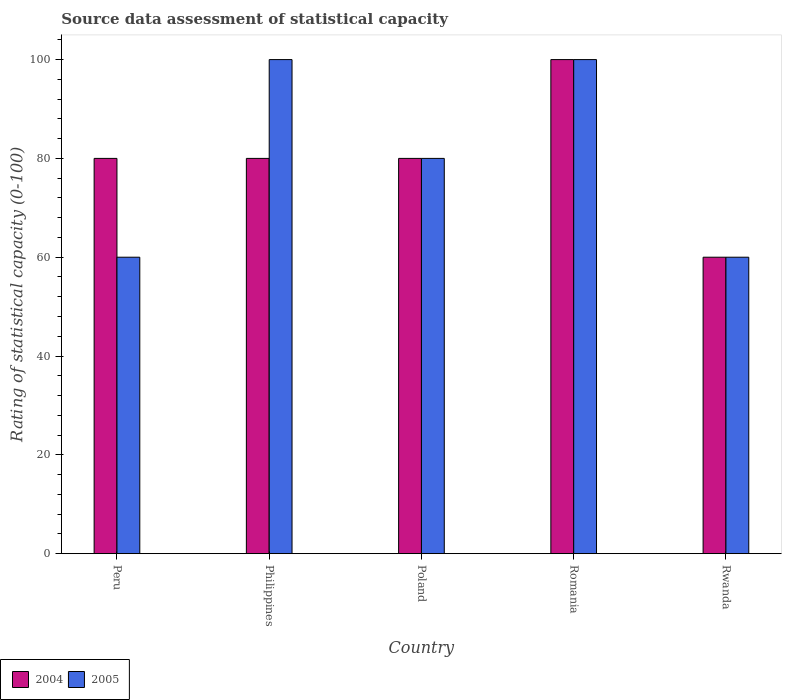How many groups of bars are there?
Your answer should be very brief. 5. Are the number of bars on each tick of the X-axis equal?
Provide a succinct answer. Yes. How many bars are there on the 5th tick from the right?
Keep it short and to the point. 2. What is the label of the 4th group of bars from the left?
Make the answer very short. Romania. Across all countries, what is the minimum rating of statistical capacity in 2004?
Make the answer very short. 60. In which country was the rating of statistical capacity in 2004 maximum?
Offer a terse response. Romania. In which country was the rating of statistical capacity in 2004 minimum?
Keep it short and to the point. Rwanda. What is the difference between the rating of statistical capacity in 2005 in Romania and the rating of statistical capacity in 2004 in Philippines?
Your answer should be compact. 20. What is the difference between the rating of statistical capacity of/in 2005 and rating of statistical capacity of/in 2004 in Philippines?
Your response must be concise. 20. What is the ratio of the rating of statistical capacity in 2005 in Poland to that in Rwanda?
Your answer should be very brief. 1.33. Is the difference between the rating of statistical capacity in 2005 in Philippines and Romania greater than the difference between the rating of statistical capacity in 2004 in Philippines and Romania?
Your answer should be very brief. Yes. What is the difference between the highest and the second highest rating of statistical capacity in 2004?
Give a very brief answer. -20. In how many countries, is the rating of statistical capacity in 2004 greater than the average rating of statistical capacity in 2004 taken over all countries?
Provide a short and direct response. 1. Is the sum of the rating of statistical capacity in 2004 in Philippines and Romania greater than the maximum rating of statistical capacity in 2005 across all countries?
Ensure brevity in your answer.  Yes. What does the 1st bar from the left in Poland represents?
Ensure brevity in your answer.  2004. What does the 2nd bar from the right in Philippines represents?
Your response must be concise. 2004. How many bars are there?
Ensure brevity in your answer.  10. Are the values on the major ticks of Y-axis written in scientific E-notation?
Offer a very short reply. No. Does the graph contain grids?
Your response must be concise. No. Where does the legend appear in the graph?
Offer a very short reply. Bottom left. How many legend labels are there?
Provide a succinct answer. 2. What is the title of the graph?
Your answer should be very brief. Source data assessment of statistical capacity. What is the label or title of the Y-axis?
Offer a very short reply. Rating of statistical capacity (0-100). What is the Rating of statistical capacity (0-100) in 2005 in Peru?
Offer a terse response. 60. What is the Rating of statistical capacity (0-100) of 2004 in Philippines?
Provide a short and direct response. 80. What is the Rating of statistical capacity (0-100) in 2005 in Poland?
Give a very brief answer. 80. What is the Rating of statistical capacity (0-100) in 2004 in Rwanda?
Provide a succinct answer. 60. Across all countries, what is the maximum Rating of statistical capacity (0-100) in 2004?
Offer a terse response. 100. Across all countries, what is the minimum Rating of statistical capacity (0-100) in 2004?
Offer a very short reply. 60. What is the total Rating of statistical capacity (0-100) in 2004 in the graph?
Your answer should be very brief. 400. What is the difference between the Rating of statistical capacity (0-100) in 2004 in Peru and that in Philippines?
Keep it short and to the point. 0. What is the difference between the Rating of statistical capacity (0-100) in 2005 in Peru and that in Poland?
Provide a short and direct response. -20. What is the difference between the Rating of statistical capacity (0-100) of 2004 in Peru and that in Romania?
Your response must be concise. -20. What is the difference between the Rating of statistical capacity (0-100) of 2004 in Peru and that in Rwanda?
Your response must be concise. 20. What is the difference between the Rating of statistical capacity (0-100) in 2005 in Peru and that in Rwanda?
Make the answer very short. 0. What is the difference between the Rating of statistical capacity (0-100) of 2004 in Philippines and that in Poland?
Give a very brief answer. 0. What is the difference between the Rating of statistical capacity (0-100) of 2005 in Philippines and that in Romania?
Your response must be concise. 0. What is the difference between the Rating of statistical capacity (0-100) in 2005 in Philippines and that in Rwanda?
Your answer should be very brief. 40. What is the difference between the Rating of statistical capacity (0-100) of 2005 in Poland and that in Rwanda?
Provide a short and direct response. 20. What is the difference between the Rating of statistical capacity (0-100) of 2005 in Romania and that in Rwanda?
Your response must be concise. 40. What is the difference between the Rating of statistical capacity (0-100) in 2004 in Peru and the Rating of statistical capacity (0-100) in 2005 in Philippines?
Your answer should be very brief. -20. What is the difference between the Rating of statistical capacity (0-100) in 2004 in Peru and the Rating of statistical capacity (0-100) in 2005 in Poland?
Provide a succinct answer. 0. What is the difference between the Rating of statistical capacity (0-100) of 2004 in Peru and the Rating of statistical capacity (0-100) of 2005 in Romania?
Offer a terse response. -20. What is the difference between the Rating of statistical capacity (0-100) in 2004 in Peru and the Rating of statistical capacity (0-100) in 2005 in Rwanda?
Your answer should be compact. 20. What is the difference between the Rating of statistical capacity (0-100) in 2004 in Poland and the Rating of statistical capacity (0-100) in 2005 in Romania?
Provide a short and direct response. -20. What is the difference between the Rating of statistical capacity (0-100) in 2004 in Romania and the Rating of statistical capacity (0-100) in 2005 in Rwanda?
Your response must be concise. 40. What is the average Rating of statistical capacity (0-100) of 2005 per country?
Your answer should be compact. 80. What is the difference between the Rating of statistical capacity (0-100) in 2004 and Rating of statistical capacity (0-100) in 2005 in Peru?
Your answer should be very brief. 20. What is the difference between the Rating of statistical capacity (0-100) in 2004 and Rating of statistical capacity (0-100) in 2005 in Romania?
Keep it short and to the point. 0. What is the ratio of the Rating of statistical capacity (0-100) in 2004 in Peru to that in Romania?
Your answer should be very brief. 0.8. What is the ratio of the Rating of statistical capacity (0-100) in 2004 in Philippines to that in Poland?
Provide a succinct answer. 1. What is the ratio of the Rating of statistical capacity (0-100) of 2005 in Philippines to that in Poland?
Make the answer very short. 1.25. What is the ratio of the Rating of statistical capacity (0-100) in 2004 in Philippines to that in Romania?
Your answer should be compact. 0.8. What is the ratio of the Rating of statistical capacity (0-100) of 2005 in Philippines to that in Romania?
Provide a short and direct response. 1. What is the ratio of the Rating of statistical capacity (0-100) in 2004 in Philippines to that in Rwanda?
Keep it short and to the point. 1.33. What is the ratio of the Rating of statistical capacity (0-100) in 2005 in Philippines to that in Rwanda?
Keep it short and to the point. 1.67. What is the ratio of the Rating of statistical capacity (0-100) in 2004 in Poland to that in Romania?
Offer a terse response. 0.8. What is the ratio of the Rating of statistical capacity (0-100) of 2004 in Poland to that in Rwanda?
Make the answer very short. 1.33. What is the ratio of the Rating of statistical capacity (0-100) in 2005 in Poland to that in Rwanda?
Your answer should be compact. 1.33. What is the ratio of the Rating of statistical capacity (0-100) in 2005 in Romania to that in Rwanda?
Ensure brevity in your answer.  1.67. What is the difference between the highest and the second highest Rating of statistical capacity (0-100) in 2004?
Your answer should be very brief. 20. What is the difference between the highest and the second highest Rating of statistical capacity (0-100) of 2005?
Offer a very short reply. 0. 